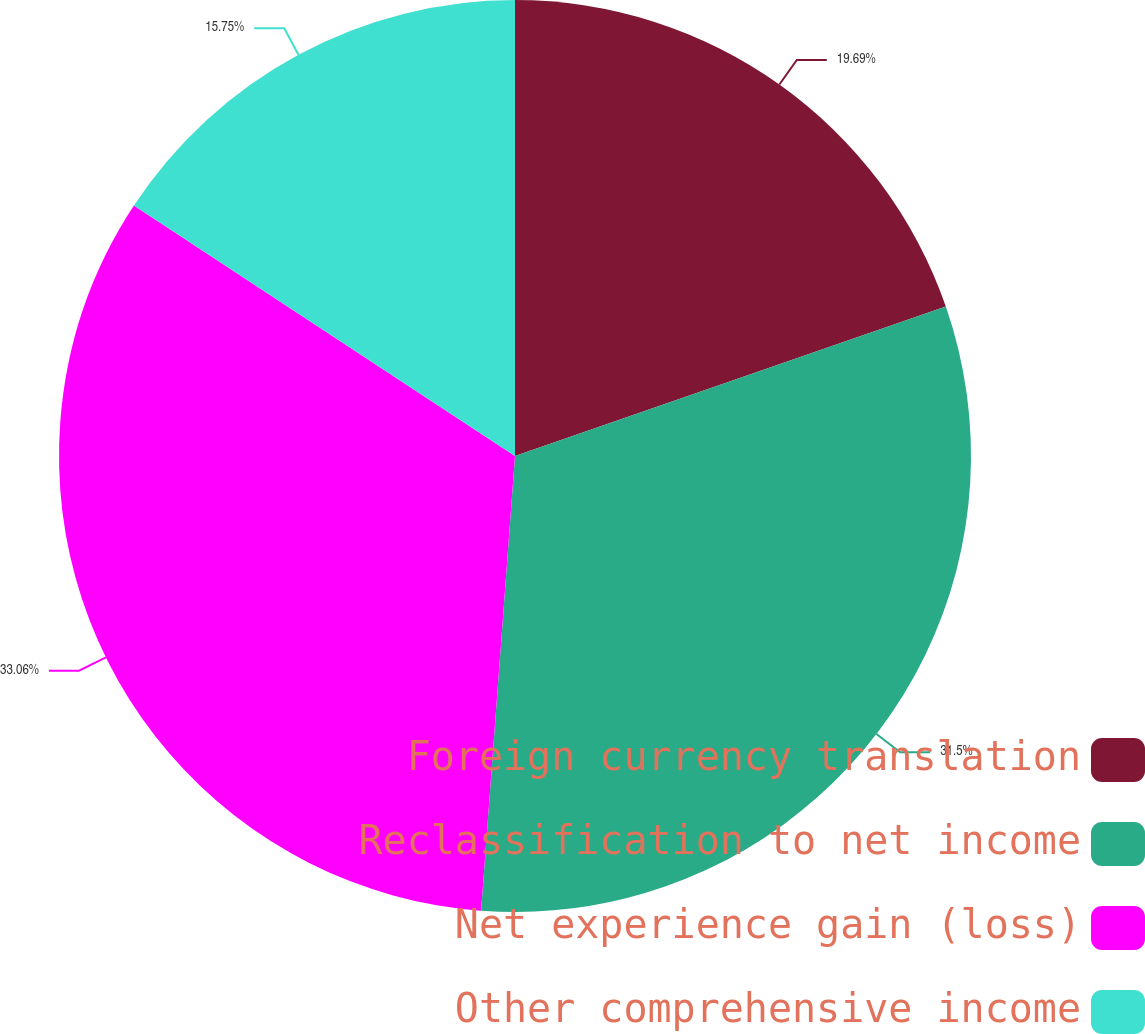Convert chart to OTSL. <chart><loc_0><loc_0><loc_500><loc_500><pie_chart><fcel>Foreign currency translation<fcel>Reclassification to net income<fcel>Net experience gain (loss)<fcel>Other comprehensive income<nl><fcel>19.69%<fcel>31.5%<fcel>33.07%<fcel>15.75%<nl></chart> 